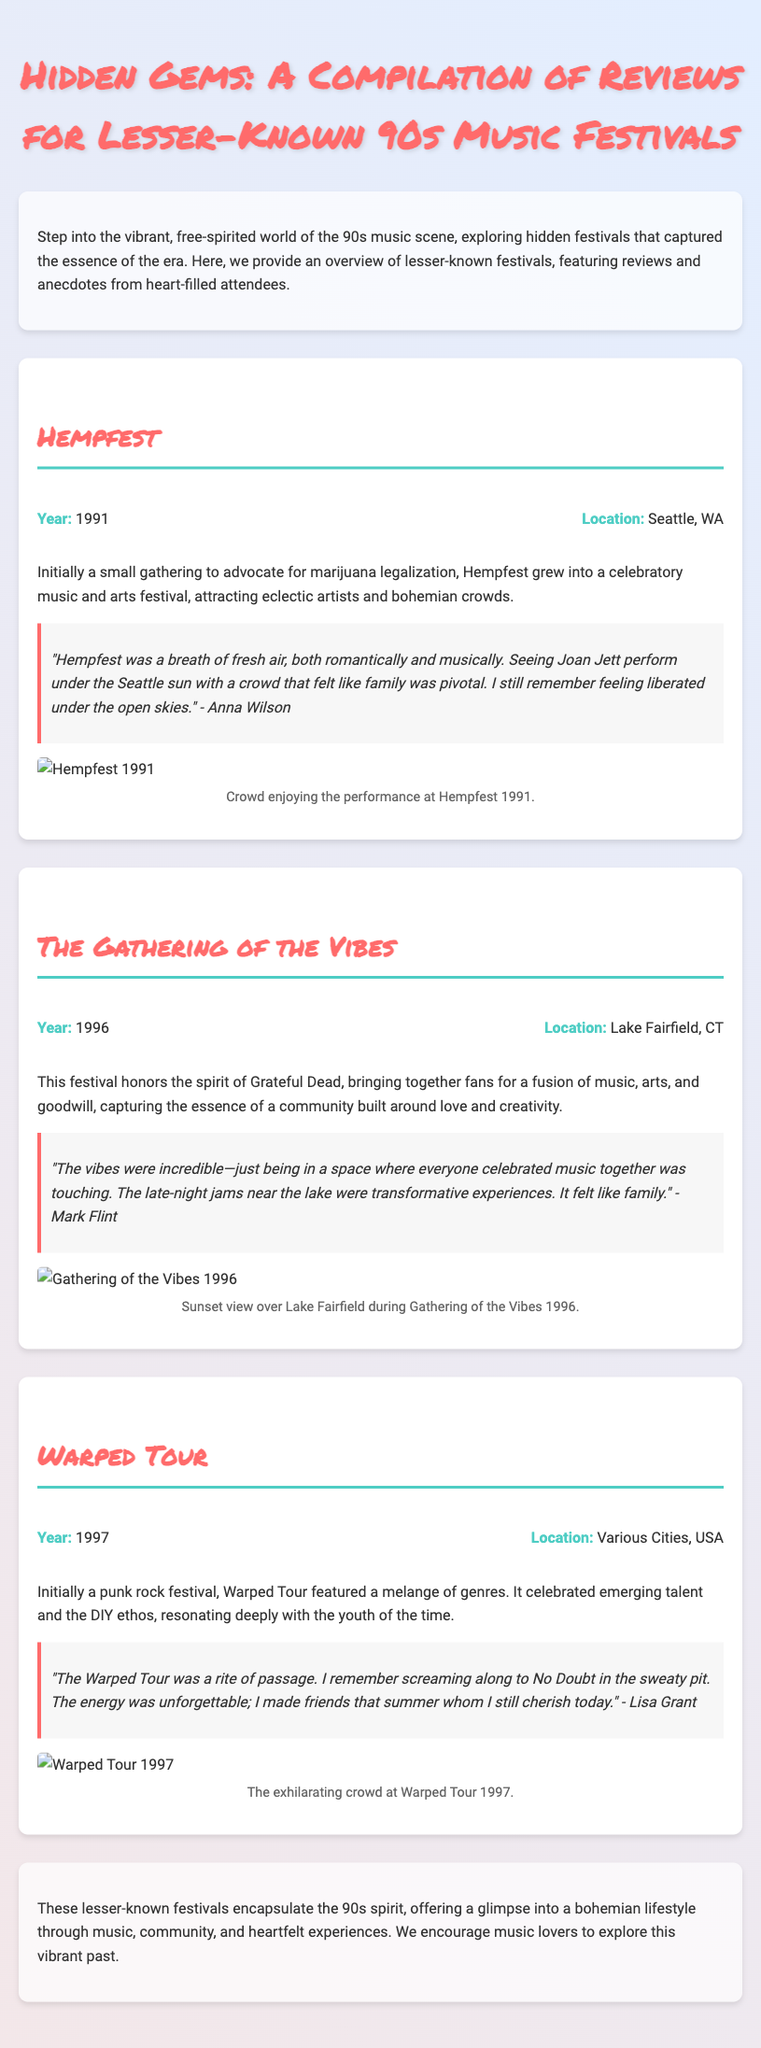What is the title of the document? The title of the document is specified in the header section, highlighting its focus on music festivals.
Answer: Hidden Gems: A Compilation of Reviews for Lesser-Known 90s Music Festivals How many festivals are discussed in the document? The document provides details on three distinct music festivals from the 90s.
Answer: 3 What year did Hempfest take place? Hempfest's year is mentioned in the festival information section within the document.
Answer: 1991 Where was The Gathering of the Vibes held? The location of The Gathering of the Vibes is detailed under the festival's profile, providing insight into its setting.
Answer: Lake Fairfield, CT Which festival featured a variety of genres? The document explains that Warped Tour, initially focused on punk rock, included a mix of music styles.
Answer: Warped Tour What quote is attributed to Anna Wilson? The document includes a personal account from Anna Wilson that captures the experience at Hempfest.
Answer: "Hempfest was a breath of fresh air, both romantically and musically..." What theme does The Gathering of the Vibes celebrate? The document indicates that The Gathering of the Vibes is centered around the spirit of a legendary band and a community experience.
Answer: Grateful Dead What sentiment is expressed about Warped Tour? The document shares a reflective sentiment from an attendee about the unforgettable experience at the Warped Tour.
Answer: "The energy was unforgettable..." 